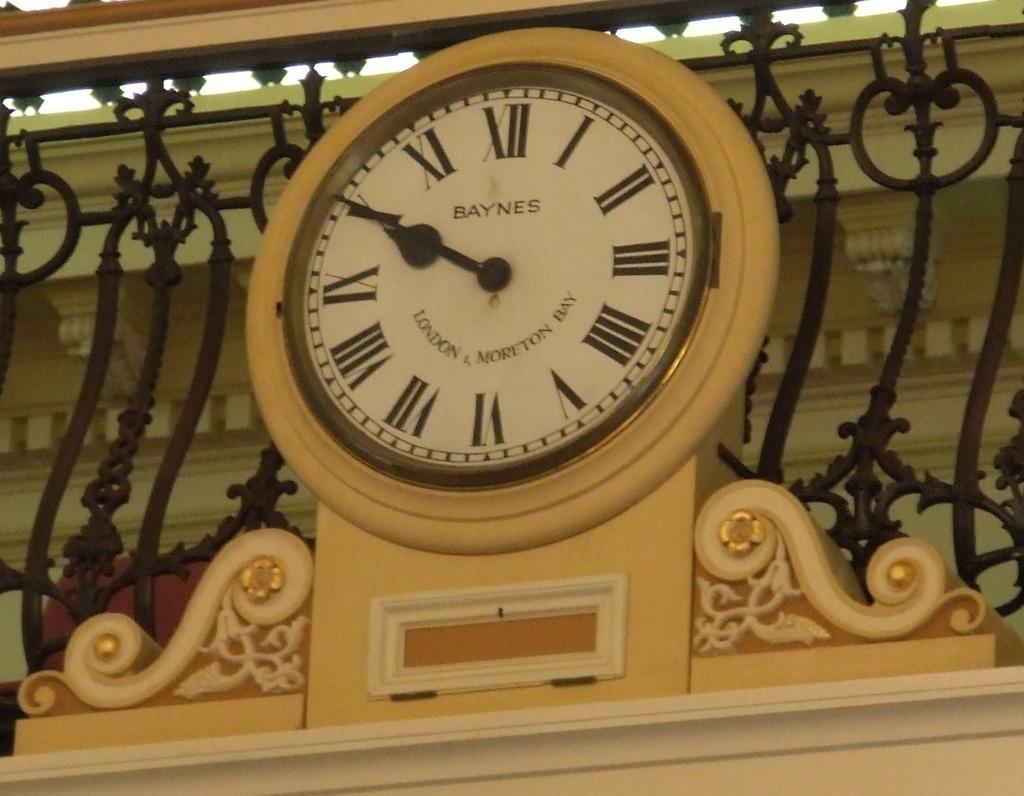What time is it on the clock?
Offer a very short reply. 10:50. Who made this clock?
Keep it short and to the point. Baynes. 